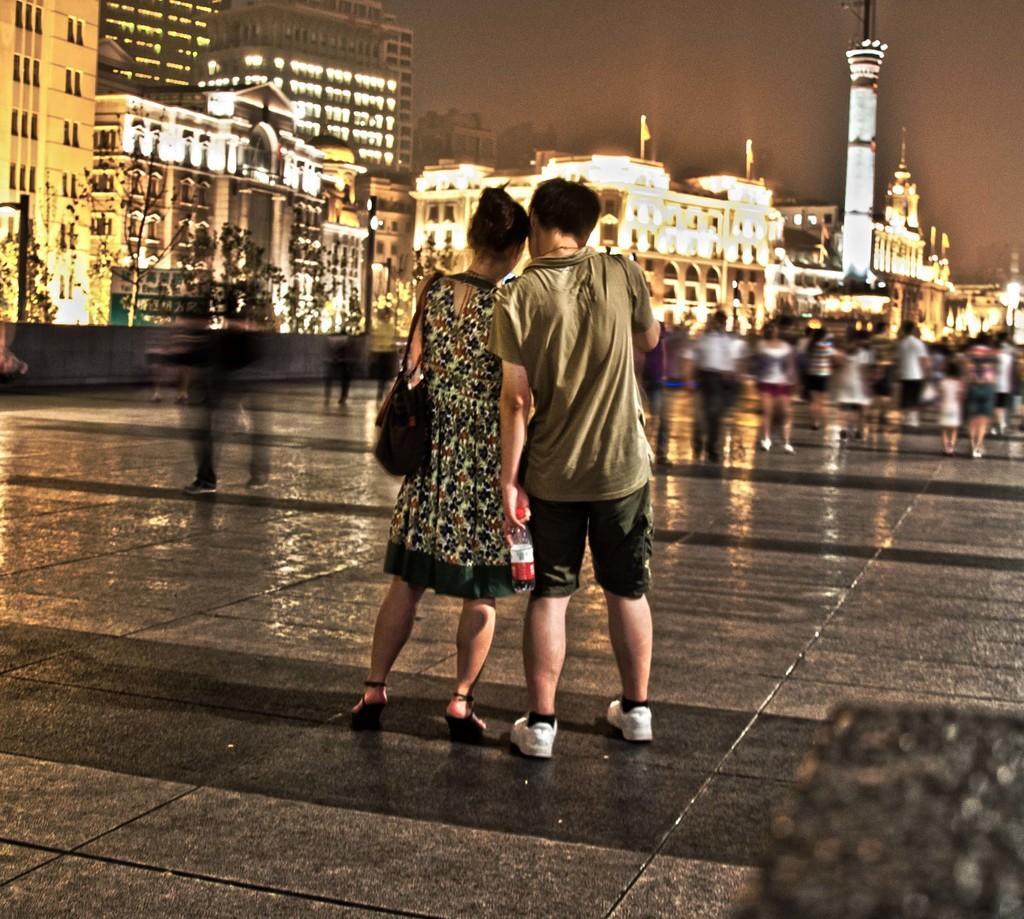How would you summarize this image in a sentence or two? In this image in the foreground there are two persons who are standing, and in the background there are a group of people who are walking and also we could see some buildings, trees and some lights. At the bottom there is a walkway. 